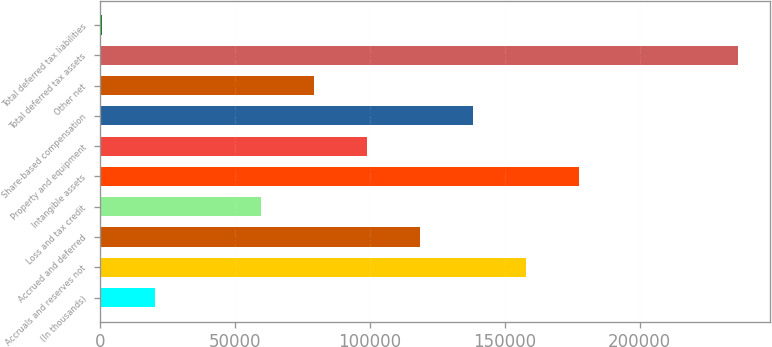<chart> <loc_0><loc_0><loc_500><loc_500><bar_chart><fcel>(In thousands)<fcel>Accruals and reserves not<fcel>Accrued and deferred<fcel>Loss and tax credit<fcel>Intangible assets<fcel>Property and equipment<fcel>Share-based compensation<fcel>Other net<fcel>Total deferred tax assets<fcel>Total deferred tax liabilities<nl><fcel>20390.5<fcel>157790<fcel>118533<fcel>59647.5<fcel>177418<fcel>98904.5<fcel>138162<fcel>79276<fcel>236304<fcel>762<nl></chart> 